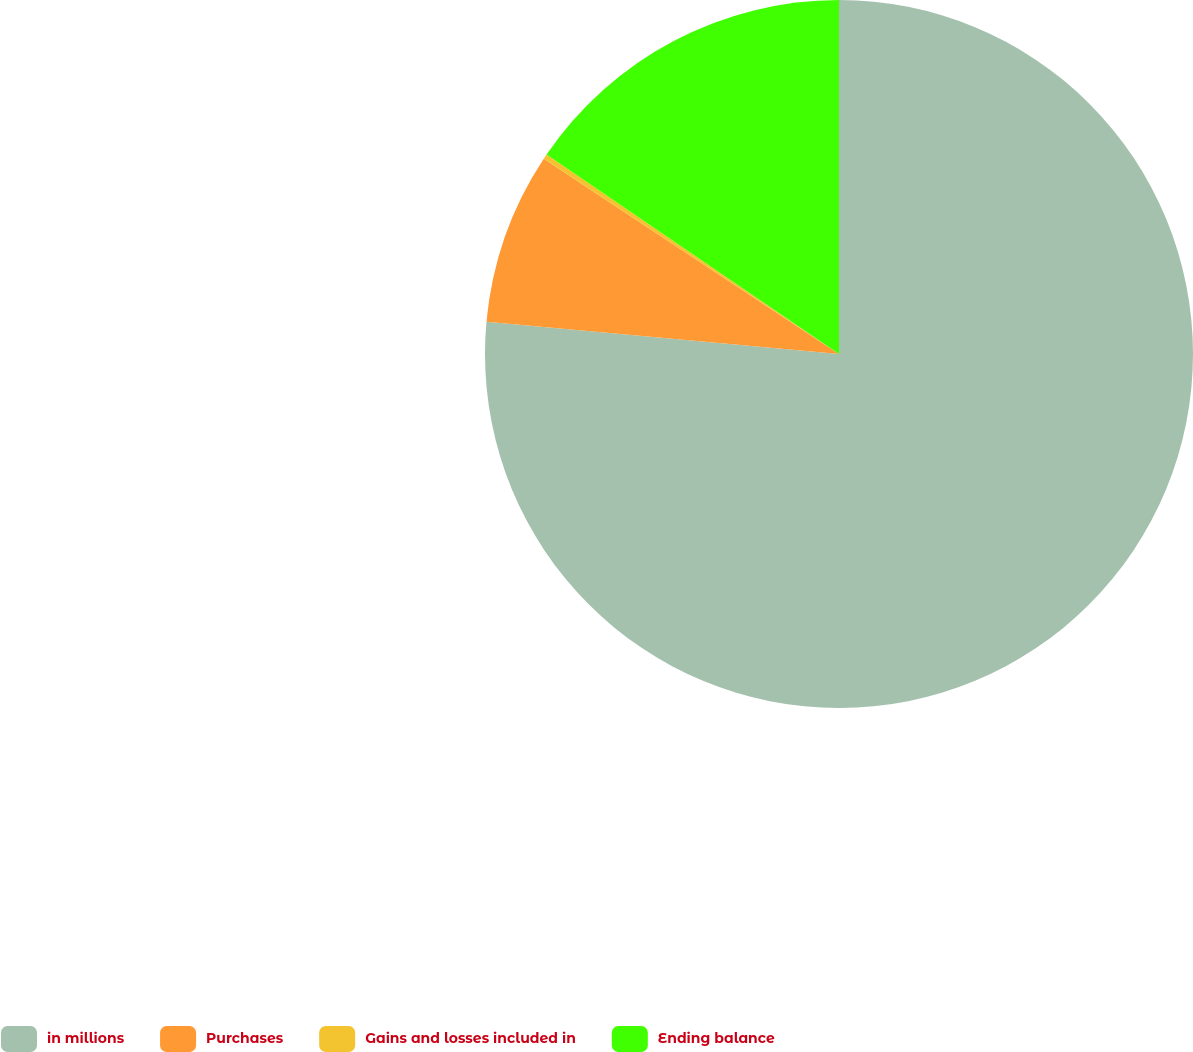<chart> <loc_0><loc_0><loc_500><loc_500><pie_chart><fcel>in millions<fcel>Purchases<fcel>Gains and losses included in<fcel>Ending balance<nl><fcel>76.45%<fcel>7.85%<fcel>0.23%<fcel>15.47%<nl></chart> 